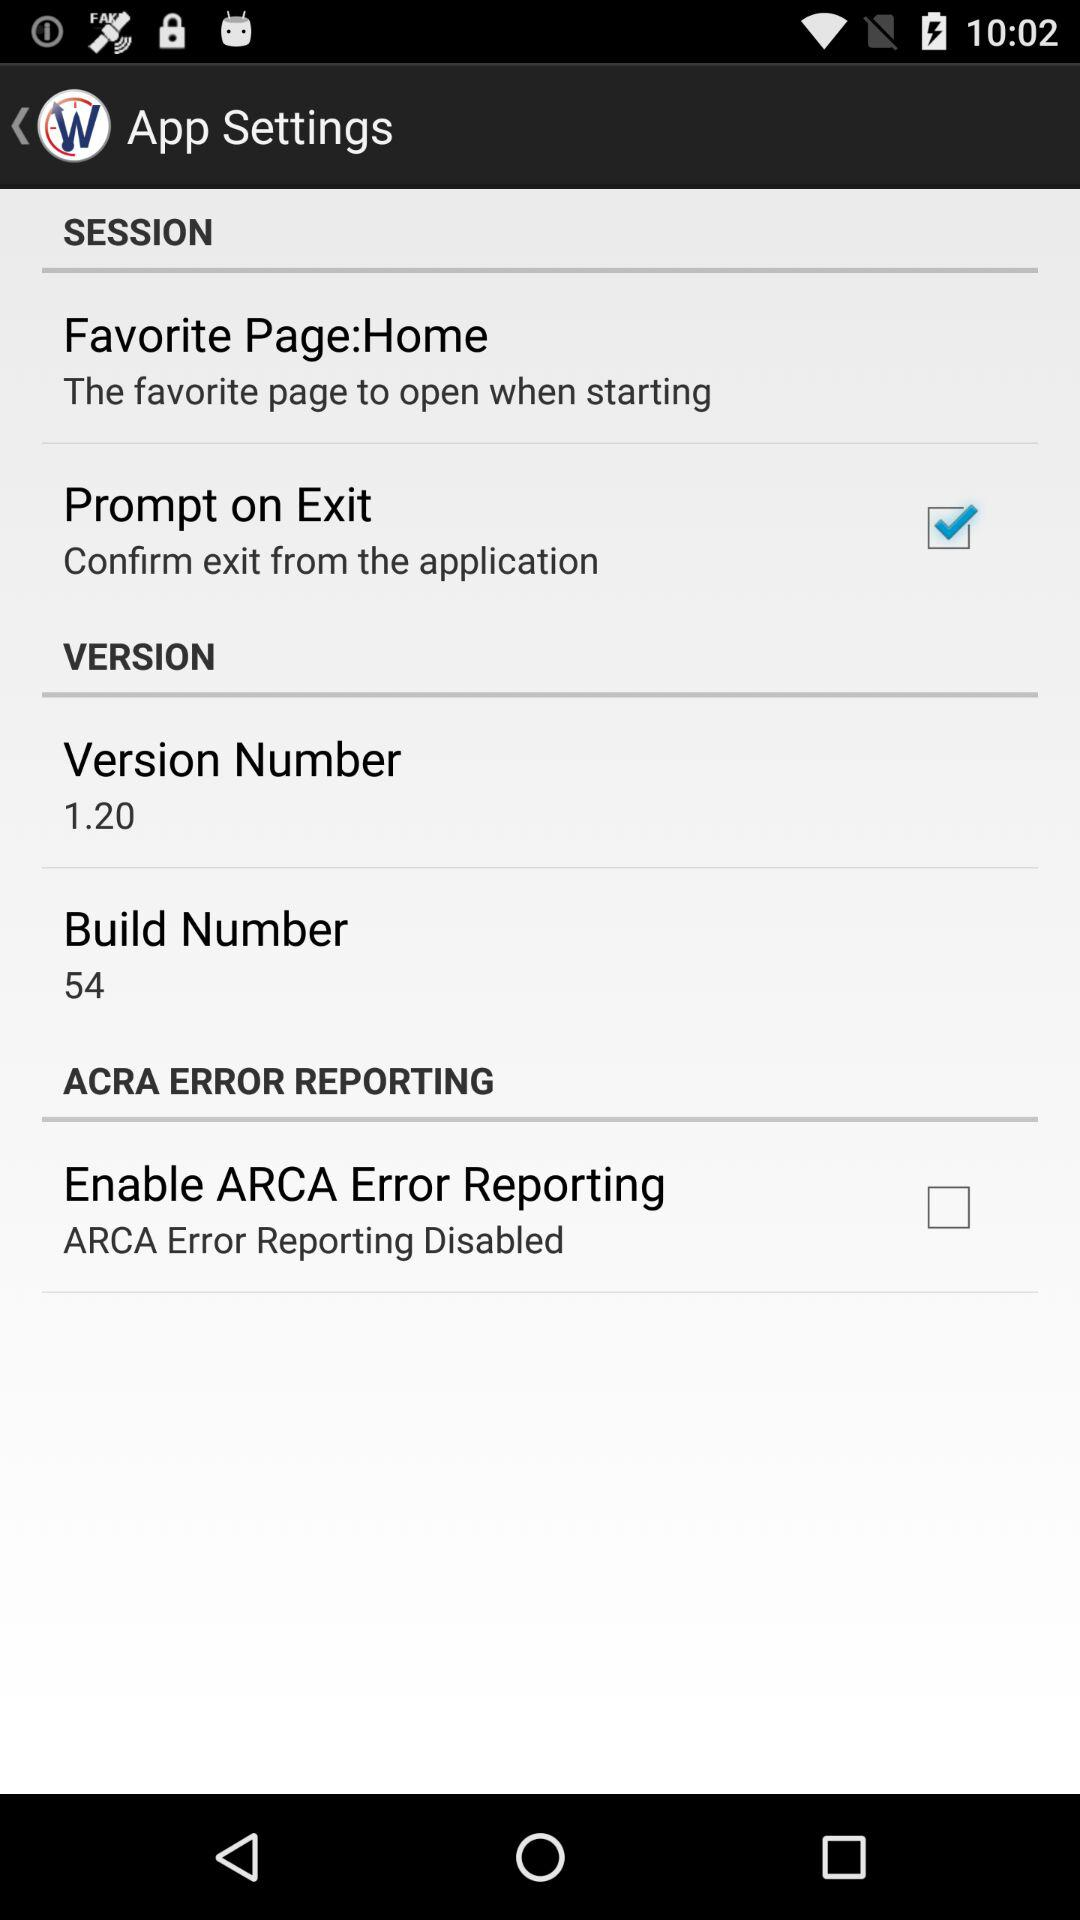What is the application version? The application version is 1.20. 